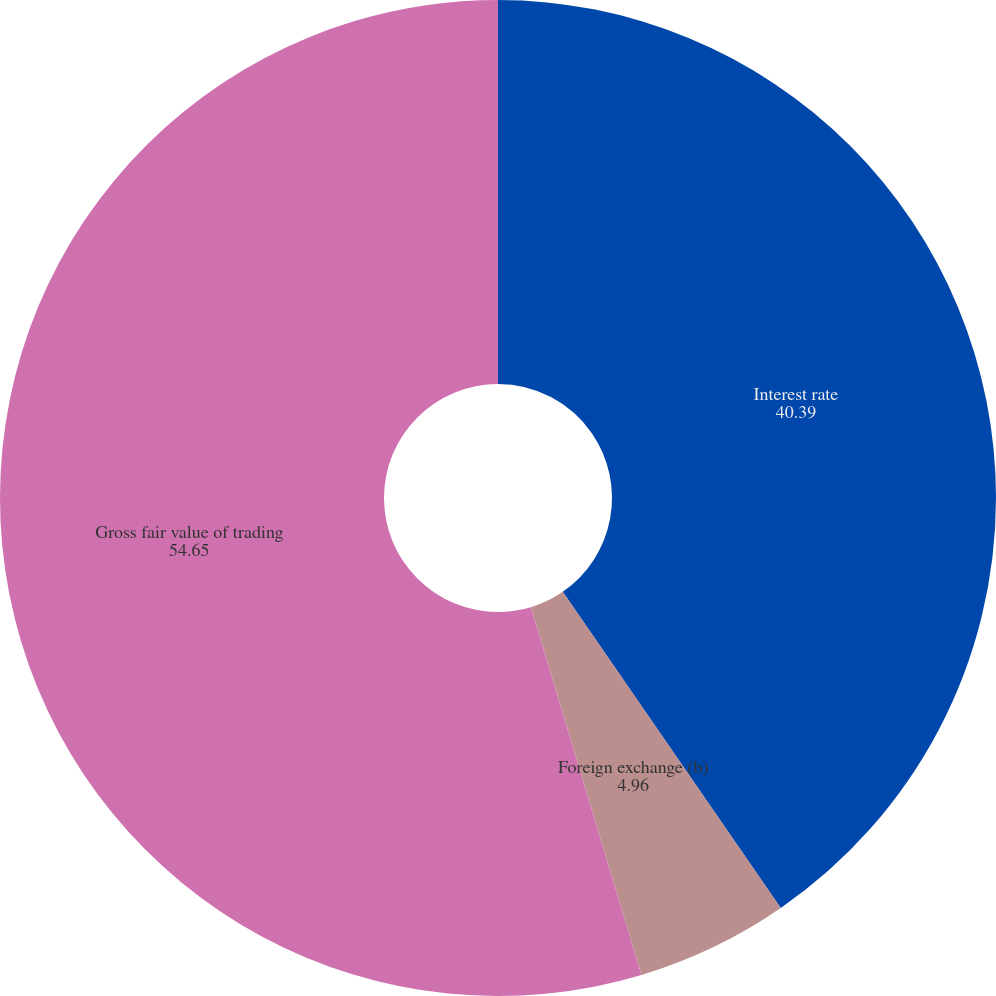Convert chart. <chart><loc_0><loc_0><loc_500><loc_500><pie_chart><fcel>Interest rate<fcel>Foreign exchange (b)<fcel>Gross fair value of trading<nl><fcel>40.39%<fcel>4.96%<fcel>54.65%<nl></chart> 